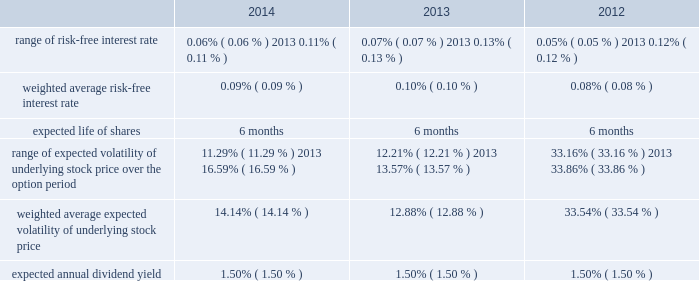American tower corporation and subsidiaries notes to consolidated financial statements six-month offering period .
The weighted average fair value per share of espp share purchase options during the year ended december 31 , 2014 , 2013 and 2012 was $ 14.83 , $ 13.42 and $ 13.64 , respectively .
At december 31 , 2014 , 3.4 million shares remain reserved for future issuance under the plan .
Key assumptions used to apply the black-scholes pricing model for shares purchased through the espp for the years ended december 31 , are as follows: .
16 .
Equity mandatory convertible preferred stock offering 2014on may 12 , 2014 , the company completed a registered public offering of 6000000 shares of its 5.25% ( 5.25 % ) mandatory convertible preferred stock , series a , par value $ 0.01 per share ( the 201cmandatory convertible preferred stock 201d ) .
The net proceeds of the offering were $ 582.9 million after deducting commissions and estimated expenses .
The company used the net proceeds from this offering to fund acquisitions , including the acquisition from richland , initially funded by indebtedness incurred under the 2013 credit facility .
Unless converted earlier , each share of the mandatory convertible preferred stock will automatically convert on may 15 , 2017 , into between 0.9174 and 1.1468 shares of common stock , depending on the applicable market value of the common stock and subject to anti-dilution adjustments .
Subject to certain restrictions , at any time prior to may 15 , 2017 , holders of the mandatory convertible preferred stock may elect to convert all or a portion of their shares into common stock at the minimum conversion rate then in effect .
Dividends on shares of mandatory convertible preferred stock are payable on a cumulative basis when , as and if declared by the company 2019s board of directors ( or an authorized committee thereof ) at an annual rate of 5.25% ( 5.25 % ) on the liquidation preference of $ 100.00 per share , on february 15 , may 15 , august 15 and november 15 of each year , commencing on august 15 , 2014 to , and including , may 15 , 2017 .
The company may pay dividends in cash or , subject to certain limitations , in shares of common stock or any combination of cash and shares of common stock .
The terms of the mandatory convertible preferred stock provide that , unless full cumulative dividends have been paid or set aside for payment on all outstanding mandatory convertible preferred stock for all prior dividend periods , no dividends may be declared or paid on common stock .
Stock repurchase program 2014in march 2011 , the board of directors approved a stock repurchase program , pursuant to which the company is authorized to purchase up to $ 1.5 billion of common stock ( 201c2011 buyback 201d ) .
In september 2013 , the company temporarily suspended repurchases in connection with its acquisition of mipt .
Under the 2011 buyback , the company is authorized to purchase shares from time to time through open market purchases or privately negotiated transactions at prevailing prices in accordance with securities laws and other legal requirements , and subject to market conditions and other factors .
To facilitate repurchases , the company .
What is the growth rate in the weighted average fair value per share of espp share purchase options from 2013 to 2014? 
Computations: ((14.83 - 13.42) / 13.42)
Answer: 0.10507. 